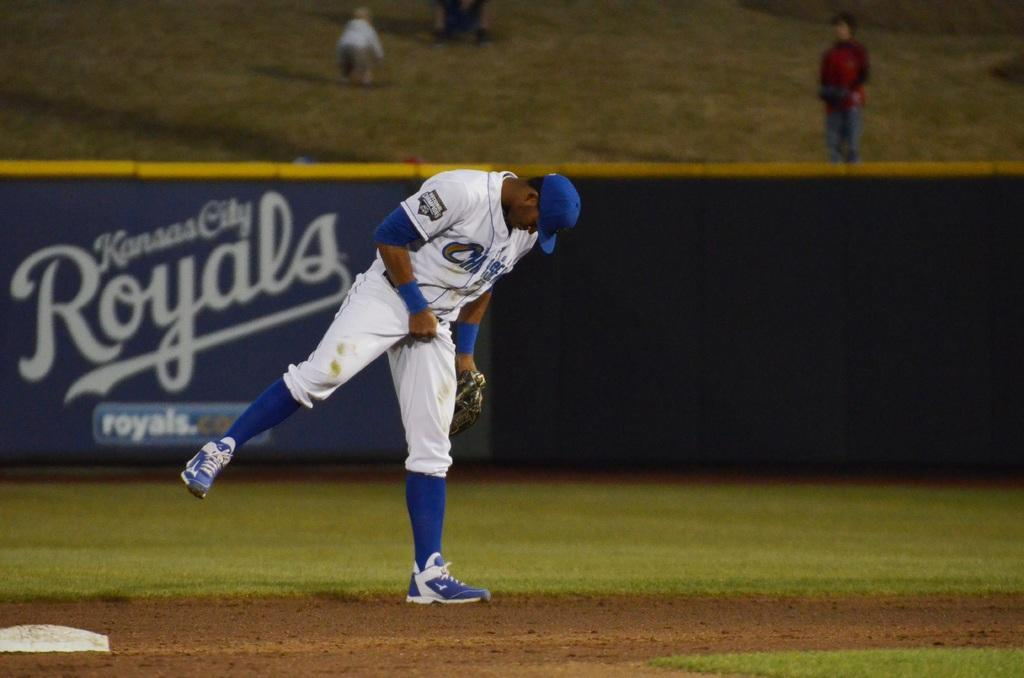<image>
Describe the image concisely. A Kansas City Royals player is shown on the baseball field grabbing his junk. 